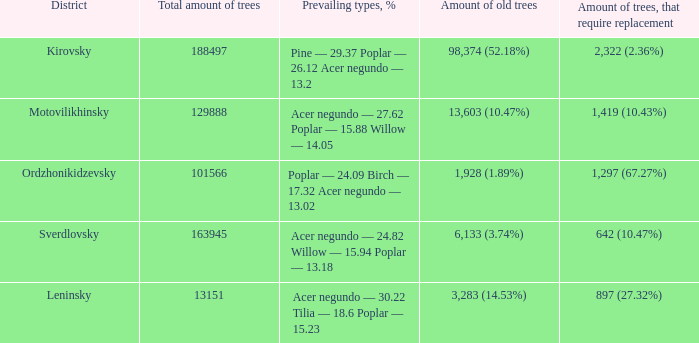What is the amount of trees, that require replacement when prevailing types, % is pine — 29.37 poplar — 26.12 acer negundo — 13.2? 2,322 (2.36%). 